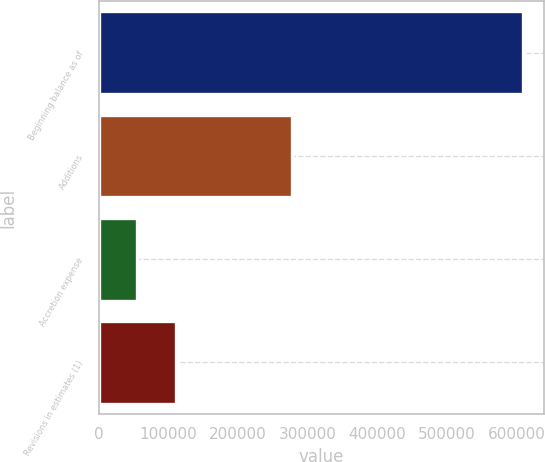<chart> <loc_0><loc_0><loc_500><loc_500><bar_chart><fcel>Beginning balance as of<fcel>Additions<fcel>Accretion expense<fcel>Revisions in estimates (1)<nl><fcel>609035<fcel>277982<fcel>55592<fcel>110936<nl></chart> 